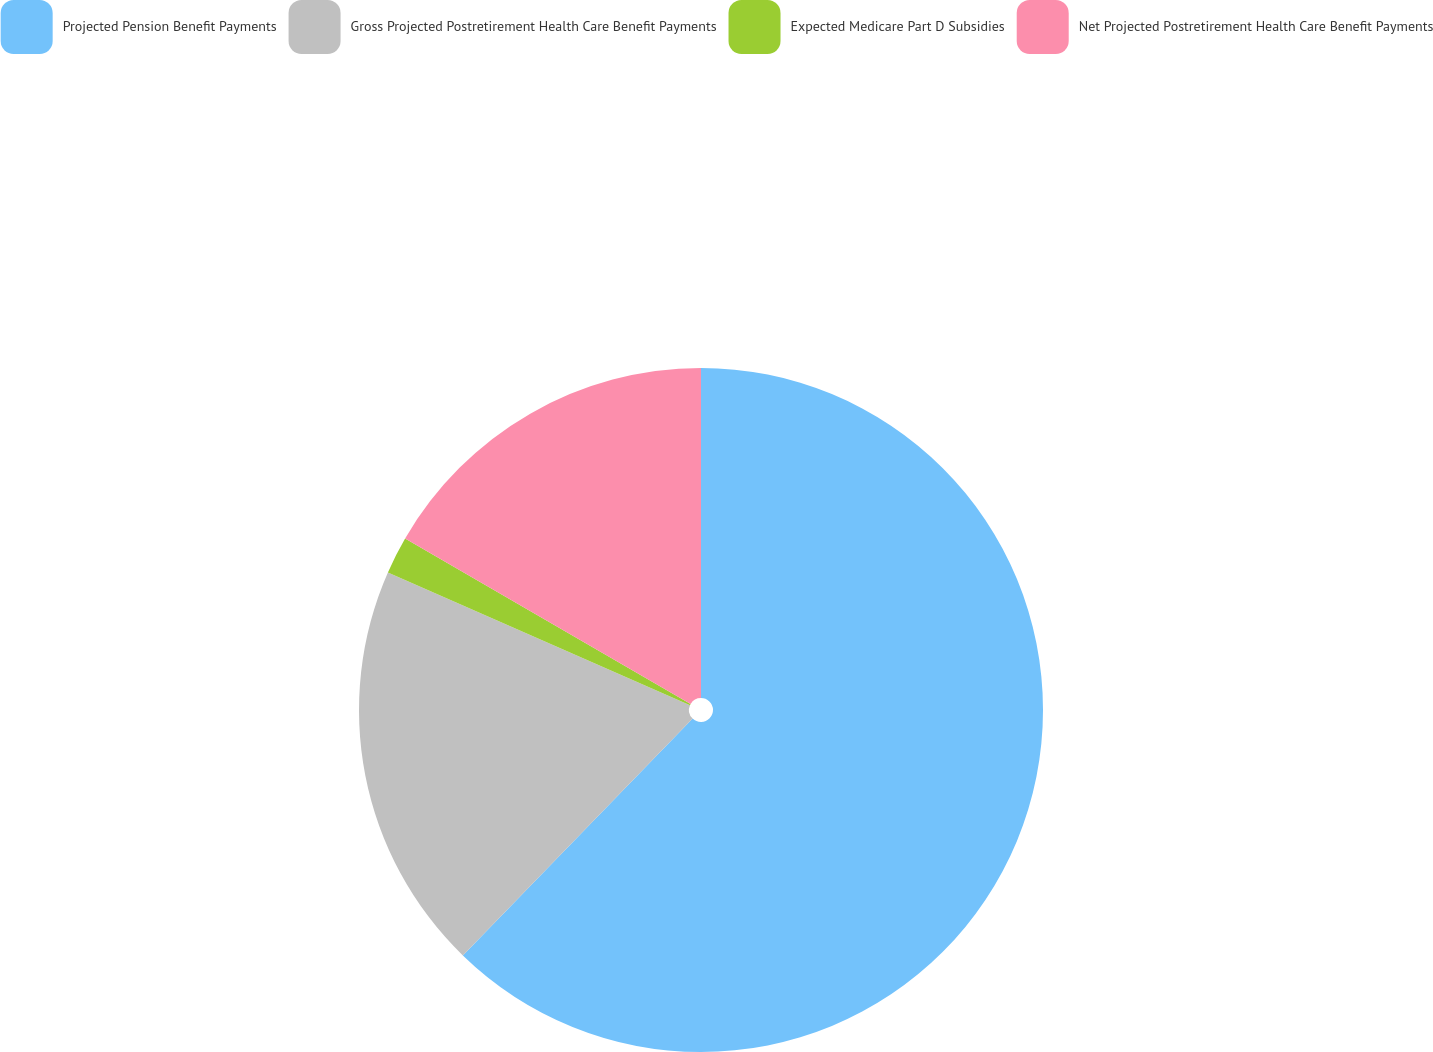Convert chart. <chart><loc_0><loc_0><loc_500><loc_500><pie_chart><fcel>Projected Pension Benefit Payments<fcel>Gross Projected Postretirement Health Care Benefit Payments<fcel>Expected Medicare Part D Subsidies<fcel>Net Projected Postretirement Health Care Benefit Payments<nl><fcel>62.26%<fcel>19.33%<fcel>1.77%<fcel>16.64%<nl></chart> 